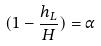Convert formula to latex. <formula><loc_0><loc_0><loc_500><loc_500>( 1 - \frac { h _ { L } } { H } ) = \alpha</formula> 